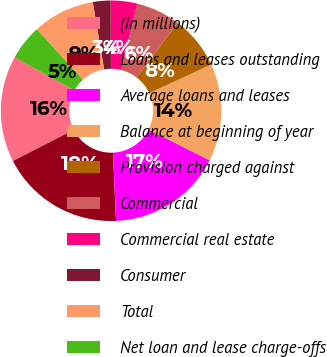Convert chart to OTSL. <chart><loc_0><loc_0><loc_500><loc_500><pie_chart><fcel>(In millions)<fcel>Loans and leases outstanding<fcel>Average loans and leases<fcel>Balance at beginning of year<fcel>Provision charged against<fcel>Commercial<fcel>Commercial real estate<fcel>Consumer<fcel>Total<fcel>Net loan and lease charge-offs<nl><fcel>15.58%<fcel>18.18%<fcel>16.88%<fcel>14.29%<fcel>7.79%<fcel>6.49%<fcel>3.9%<fcel>2.6%<fcel>9.09%<fcel>5.19%<nl></chart> 